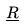<formula> <loc_0><loc_0><loc_500><loc_500>\underline { R }</formula> 